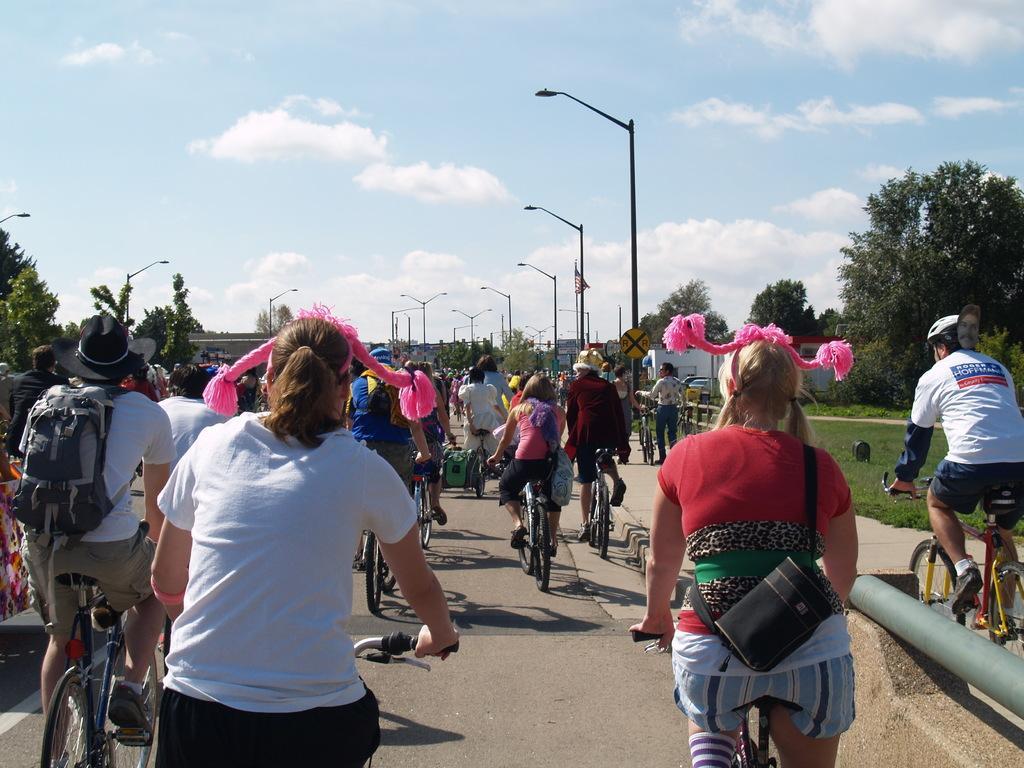In one or two sentences, can you explain what this image depicts? In this image there are group of people riding a bicycle on the right side person wearing a white colour shirt and white colour helmet is riding a bicycle on the pavement in front of him the person standing on the pavement and holding a bicycle. In the center this woman wearing a red colour t-shirt is wearing a pink colour hair band and backpack which is black in colour left to her woman with a white colour t-shirt is wearing a pink colour hairband. In the background there are some trees,grass on the floor streetlights in the cloud there are in the sky there are some clouds which are visible. 